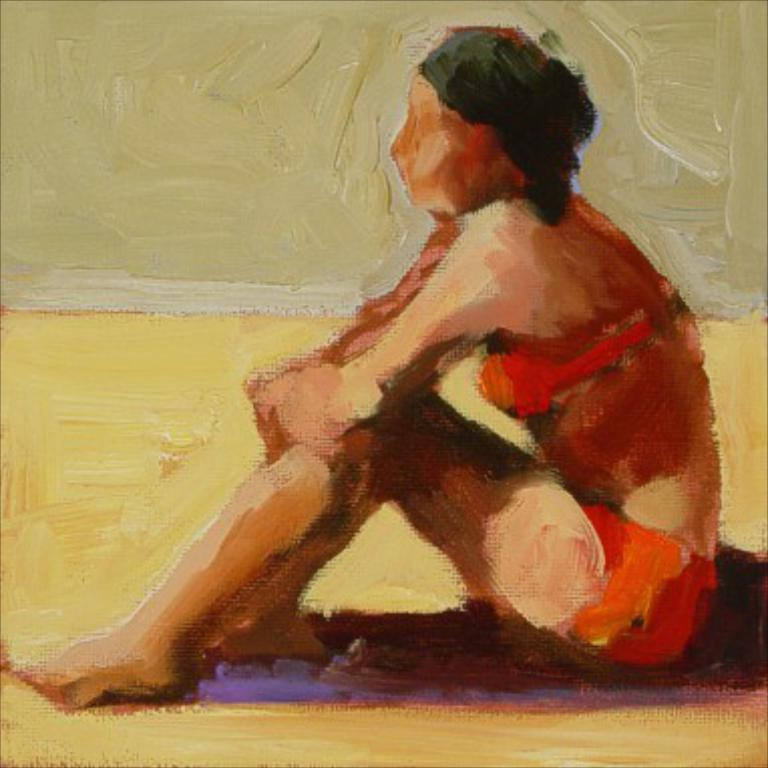What is the main subject of the image? There is a painting in the image. What is the painting depicting? The painting depicts a person sitting. Reasoning: Let's think step by step by step in order to produce the conversation. We start by identifying the main subject of the image, which is the painting. Then, we describe the content of the painting, focusing on the person sitting. Each question is designed to elicit a specific detail about the image that is known from the provided facts. Absurd Question/Answer: How many cracks can be seen in the painting? There is no mention of cracks in the painting, so we cannot determine the number of cracks from the image. What day of the week is depicted in the painting? The painting does not depict a specific day of the week; it only shows a person sitting. Are there any lizards visible in the painting? There is no mention of lizards in the painting, so we cannot determine if any are present from the image. 